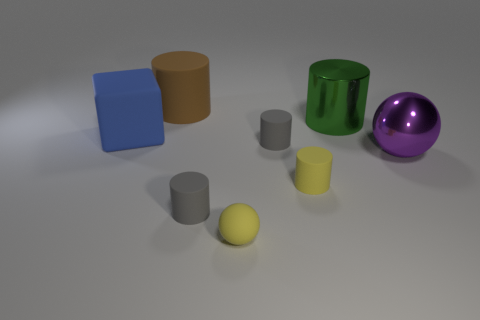Which object seems to have the most reflective surface? The purple sphere on the right has the most reflective surface, indicating a material like polished metal or glass. 